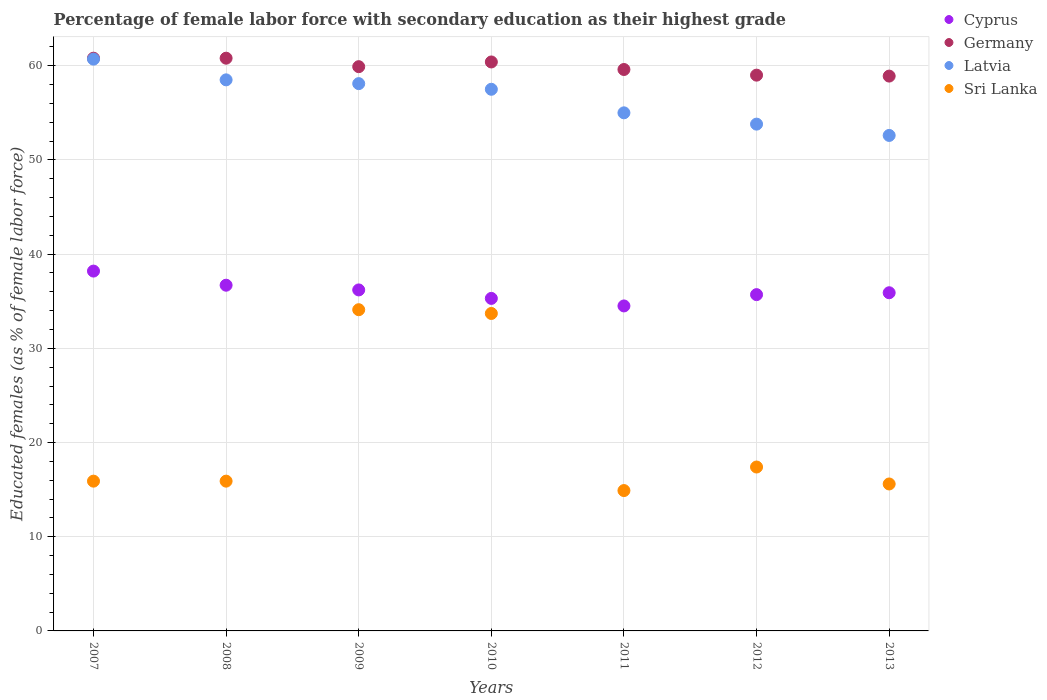How many different coloured dotlines are there?
Keep it short and to the point. 4. What is the percentage of female labor force with secondary education in Cyprus in 2008?
Your answer should be compact. 36.7. Across all years, what is the maximum percentage of female labor force with secondary education in Latvia?
Your answer should be very brief. 60.7. Across all years, what is the minimum percentage of female labor force with secondary education in Germany?
Your answer should be very brief. 58.9. In which year was the percentage of female labor force with secondary education in Sri Lanka minimum?
Give a very brief answer. 2011. What is the total percentage of female labor force with secondary education in Cyprus in the graph?
Offer a very short reply. 252.5. What is the difference between the percentage of female labor force with secondary education in Sri Lanka in 2007 and that in 2013?
Keep it short and to the point. 0.3. What is the difference between the percentage of female labor force with secondary education in Latvia in 2011 and the percentage of female labor force with secondary education in Cyprus in 2008?
Give a very brief answer. 18.3. What is the average percentage of female labor force with secondary education in Cyprus per year?
Offer a terse response. 36.07. In the year 2008, what is the difference between the percentage of female labor force with secondary education in Latvia and percentage of female labor force with secondary education in Germany?
Make the answer very short. -2.3. In how many years, is the percentage of female labor force with secondary education in Germany greater than 10 %?
Provide a succinct answer. 7. What is the ratio of the percentage of female labor force with secondary education in Germany in 2007 to that in 2011?
Your response must be concise. 1.02. Is the percentage of female labor force with secondary education in Sri Lanka in 2010 less than that in 2012?
Make the answer very short. No. What is the difference between the highest and the second highest percentage of female labor force with secondary education in Latvia?
Give a very brief answer. 2.2. What is the difference between the highest and the lowest percentage of female labor force with secondary education in Latvia?
Keep it short and to the point. 8.1. Is the sum of the percentage of female labor force with secondary education in Sri Lanka in 2007 and 2011 greater than the maximum percentage of female labor force with secondary education in Cyprus across all years?
Keep it short and to the point. No. Is it the case that in every year, the sum of the percentage of female labor force with secondary education in Sri Lanka and percentage of female labor force with secondary education in Cyprus  is greater than the sum of percentage of female labor force with secondary education in Latvia and percentage of female labor force with secondary education in Germany?
Keep it short and to the point. No. Is the percentage of female labor force with secondary education in Cyprus strictly less than the percentage of female labor force with secondary education in Latvia over the years?
Your answer should be compact. Yes. How many years are there in the graph?
Give a very brief answer. 7. Are the values on the major ticks of Y-axis written in scientific E-notation?
Make the answer very short. No. Does the graph contain any zero values?
Offer a very short reply. No. Does the graph contain grids?
Give a very brief answer. Yes. Where does the legend appear in the graph?
Your answer should be very brief. Top right. How are the legend labels stacked?
Your answer should be compact. Vertical. What is the title of the graph?
Give a very brief answer. Percentage of female labor force with secondary education as their highest grade. Does "India" appear as one of the legend labels in the graph?
Provide a short and direct response. No. What is the label or title of the X-axis?
Provide a succinct answer. Years. What is the label or title of the Y-axis?
Provide a short and direct response. Educated females (as % of female labor force). What is the Educated females (as % of female labor force) of Cyprus in 2007?
Make the answer very short. 38.2. What is the Educated females (as % of female labor force) of Germany in 2007?
Your response must be concise. 60.8. What is the Educated females (as % of female labor force) of Latvia in 2007?
Provide a succinct answer. 60.7. What is the Educated females (as % of female labor force) of Sri Lanka in 2007?
Offer a terse response. 15.9. What is the Educated females (as % of female labor force) of Cyprus in 2008?
Keep it short and to the point. 36.7. What is the Educated females (as % of female labor force) of Germany in 2008?
Your response must be concise. 60.8. What is the Educated females (as % of female labor force) of Latvia in 2008?
Your answer should be very brief. 58.5. What is the Educated females (as % of female labor force) of Sri Lanka in 2008?
Provide a succinct answer. 15.9. What is the Educated females (as % of female labor force) of Cyprus in 2009?
Make the answer very short. 36.2. What is the Educated females (as % of female labor force) in Germany in 2009?
Make the answer very short. 59.9. What is the Educated females (as % of female labor force) of Latvia in 2009?
Ensure brevity in your answer.  58.1. What is the Educated females (as % of female labor force) in Sri Lanka in 2009?
Make the answer very short. 34.1. What is the Educated females (as % of female labor force) of Cyprus in 2010?
Provide a succinct answer. 35.3. What is the Educated females (as % of female labor force) in Germany in 2010?
Ensure brevity in your answer.  60.4. What is the Educated females (as % of female labor force) of Latvia in 2010?
Offer a terse response. 57.5. What is the Educated females (as % of female labor force) of Sri Lanka in 2010?
Ensure brevity in your answer.  33.7. What is the Educated females (as % of female labor force) of Cyprus in 2011?
Ensure brevity in your answer.  34.5. What is the Educated females (as % of female labor force) in Germany in 2011?
Ensure brevity in your answer.  59.6. What is the Educated females (as % of female labor force) in Sri Lanka in 2011?
Provide a succinct answer. 14.9. What is the Educated females (as % of female labor force) of Cyprus in 2012?
Provide a short and direct response. 35.7. What is the Educated females (as % of female labor force) in Latvia in 2012?
Ensure brevity in your answer.  53.8. What is the Educated females (as % of female labor force) of Sri Lanka in 2012?
Your answer should be compact. 17.4. What is the Educated females (as % of female labor force) in Cyprus in 2013?
Give a very brief answer. 35.9. What is the Educated females (as % of female labor force) in Germany in 2013?
Provide a succinct answer. 58.9. What is the Educated females (as % of female labor force) of Latvia in 2013?
Your answer should be very brief. 52.6. What is the Educated females (as % of female labor force) in Sri Lanka in 2013?
Your response must be concise. 15.6. Across all years, what is the maximum Educated females (as % of female labor force) of Cyprus?
Provide a short and direct response. 38.2. Across all years, what is the maximum Educated females (as % of female labor force) in Germany?
Offer a terse response. 60.8. Across all years, what is the maximum Educated females (as % of female labor force) in Latvia?
Your response must be concise. 60.7. Across all years, what is the maximum Educated females (as % of female labor force) of Sri Lanka?
Your answer should be compact. 34.1. Across all years, what is the minimum Educated females (as % of female labor force) of Cyprus?
Ensure brevity in your answer.  34.5. Across all years, what is the minimum Educated females (as % of female labor force) in Germany?
Provide a short and direct response. 58.9. Across all years, what is the minimum Educated females (as % of female labor force) in Latvia?
Your response must be concise. 52.6. Across all years, what is the minimum Educated females (as % of female labor force) of Sri Lanka?
Offer a very short reply. 14.9. What is the total Educated females (as % of female labor force) of Cyprus in the graph?
Keep it short and to the point. 252.5. What is the total Educated females (as % of female labor force) of Germany in the graph?
Provide a short and direct response. 419.4. What is the total Educated females (as % of female labor force) of Latvia in the graph?
Your answer should be compact. 396.2. What is the total Educated females (as % of female labor force) of Sri Lanka in the graph?
Make the answer very short. 147.5. What is the difference between the Educated females (as % of female labor force) of Cyprus in 2007 and that in 2008?
Your answer should be very brief. 1.5. What is the difference between the Educated females (as % of female labor force) of Sri Lanka in 2007 and that in 2008?
Offer a very short reply. 0. What is the difference between the Educated females (as % of female labor force) in Cyprus in 2007 and that in 2009?
Ensure brevity in your answer.  2. What is the difference between the Educated females (as % of female labor force) of Germany in 2007 and that in 2009?
Offer a terse response. 0.9. What is the difference between the Educated females (as % of female labor force) in Sri Lanka in 2007 and that in 2009?
Make the answer very short. -18.2. What is the difference between the Educated females (as % of female labor force) in Germany in 2007 and that in 2010?
Your answer should be compact. 0.4. What is the difference between the Educated females (as % of female labor force) in Latvia in 2007 and that in 2010?
Keep it short and to the point. 3.2. What is the difference between the Educated females (as % of female labor force) of Sri Lanka in 2007 and that in 2010?
Provide a succinct answer. -17.8. What is the difference between the Educated females (as % of female labor force) in Germany in 2007 and that in 2011?
Give a very brief answer. 1.2. What is the difference between the Educated females (as % of female labor force) of Germany in 2007 and that in 2012?
Your response must be concise. 1.8. What is the difference between the Educated females (as % of female labor force) in Latvia in 2007 and that in 2012?
Ensure brevity in your answer.  6.9. What is the difference between the Educated females (as % of female labor force) of Sri Lanka in 2007 and that in 2012?
Offer a very short reply. -1.5. What is the difference between the Educated females (as % of female labor force) in Germany in 2007 and that in 2013?
Give a very brief answer. 1.9. What is the difference between the Educated females (as % of female labor force) in Latvia in 2007 and that in 2013?
Offer a terse response. 8.1. What is the difference between the Educated females (as % of female labor force) in Sri Lanka in 2007 and that in 2013?
Offer a very short reply. 0.3. What is the difference between the Educated females (as % of female labor force) of Cyprus in 2008 and that in 2009?
Your answer should be compact. 0.5. What is the difference between the Educated females (as % of female labor force) of Germany in 2008 and that in 2009?
Your answer should be compact. 0.9. What is the difference between the Educated females (as % of female labor force) in Latvia in 2008 and that in 2009?
Ensure brevity in your answer.  0.4. What is the difference between the Educated females (as % of female labor force) in Sri Lanka in 2008 and that in 2009?
Provide a succinct answer. -18.2. What is the difference between the Educated females (as % of female labor force) in Latvia in 2008 and that in 2010?
Offer a terse response. 1. What is the difference between the Educated females (as % of female labor force) of Sri Lanka in 2008 and that in 2010?
Your response must be concise. -17.8. What is the difference between the Educated females (as % of female labor force) of Cyprus in 2008 and that in 2011?
Your answer should be compact. 2.2. What is the difference between the Educated females (as % of female labor force) in Germany in 2008 and that in 2011?
Give a very brief answer. 1.2. What is the difference between the Educated females (as % of female labor force) of Latvia in 2008 and that in 2011?
Your answer should be compact. 3.5. What is the difference between the Educated females (as % of female labor force) in Cyprus in 2008 and that in 2012?
Your answer should be very brief. 1. What is the difference between the Educated females (as % of female labor force) of Latvia in 2008 and that in 2012?
Offer a very short reply. 4.7. What is the difference between the Educated females (as % of female labor force) in Latvia in 2008 and that in 2013?
Provide a succinct answer. 5.9. What is the difference between the Educated females (as % of female labor force) in Cyprus in 2009 and that in 2010?
Provide a short and direct response. 0.9. What is the difference between the Educated females (as % of female labor force) in Latvia in 2009 and that in 2010?
Offer a terse response. 0.6. What is the difference between the Educated females (as % of female labor force) of Sri Lanka in 2009 and that in 2010?
Offer a terse response. 0.4. What is the difference between the Educated females (as % of female labor force) in Cyprus in 2009 and that in 2011?
Offer a terse response. 1.7. What is the difference between the Educated females (as % of female labor force) in Sri Lanka in 2009 and that in 2011?
Give a very brief answer. 19.2. What is the difference between the Educated females (as % of female labor force) in Germany in 2009 and that in 2012?
Offer a very short reply. 0.9. What is the difference between the Educated females (as % of female labor force) of Latvia in 2009 and that in 2012?
Your response must be concise. 4.3. What is the difference between the Educated females (as % of female labor force) of Sri Lanka in 2009 and that in 2012?
Provide a succinct answer. 16.7. What is the difference between the Educated females (as % of female labor force) in Germany in 2009 and that in 2013?
Ensure brevity in your answer.  1. What is the difference between the Educated females (as % of female labor force) of Sri Lanka in 2009 and that in 2013?
Provide a short and direct response. 18.5. What is the difference between the Educated females (as % of female labor force) of Germany in 2010 and that in 2011?
Make the answer very short. 0.8. What is the difference between the Educated females (as % of female labor force) of Latvia in 2010 and that in 2011?
Provide a short and direct response. 2.5. What is the difference between the Educated females (as % of female labor force) of Sri Lanka in 2010 and that in 2011?
Ensure brevity in your answer.  18.8. What is the difference between the Educated females (as % of female labor force) of Germany in 2010 and that in 2012?
Offer a terse response. 1.4. What is the difference between the Educated females (as % of female labor force) of Latvia in 2010 and that in 2012?
Give a very brief answer. 3.7. What is the difference between the Educated females (as % of female labor force) in Sri Lanka in 2010 and that in 2012?
Provide a short and direct response. 16.3. What is the difference between the Educated females (as % of female labor force) in Cyprus in 2010 and that in 2013?
Offer a very short reply. -0.6. What is the difference between the Educated females (as % of female labor force) in Latvia in 2010 and that in 2013?
Provide a succinct answer. 4.9. What is the difference between the Educated females (as % of female labor force) in Sri Lanka in 2010 and that in 2013?
Offer a terse response. 18.1. What is the difference between the Educated females (as % of female labor force) in Cyprus in 2011 and that in 2012?
Your answer should be very brief. -1.2. What is the difference between the Educated females (as % of female labor force) in Germany in 2011 and that in 2012?
Offer a terse response. 0.6. What is the difference between the Educated females (as % of female labor force) in Latvia in 2011 and that in 2012?
Provide a short and direct response. 1.2. What is the difference between the Educated females (as % of female labor force) in Sri Lanka in 2011 and that in 2012?
Offer a terse response. -2.5. What is the difference between the Educated females (as % of female labor force) of Cyprus in 2012 and that in 2013?
Your response must be concise. -0.2. What is the difference between the Educated females (as % of female labor force) of Latvia in 2012 and that in 2013?
Give a very brief answer. 1.2. What is the difference between the Educated females (as % of female labor force) in Cyprus in 2007 and the Educated females (as % of female labor force) in Germany in 2008?
Your answer should be very brief. -22.6. What is the difference between the Educated females (as % of female labor force) of Cyprus in 2007 and the Educated females (as % of female labor force) of Latvia in 2008?
Offer a terse response. -20.3. What is the difference between the Educated females (as % of female labor force) in Cyprus in 2007 and the Educated females (as % of female labor force) in Sri Lanka in 2008?
Provide a succinct answer. 22.3. What is the difference between the Educated females (as % of female labor force) of Germany in 2007 and the Educated females (as % of female labor force) of Sri Lanka in 2008?
Ensure brevity in your answer.  44.9. What is the difference between the Educated females (as % of female labor force) in Latvia in 2007 and the Educated females (as % of female labor force) in Sri Lanka in 2008?
Give a very brief answer. 44.8. What is the difference between the Educated females (as % of female labor force) in Cyprus in 2007 and the Educated females (as % of female labor force) in Germany in 2009?
Provide a succinct answer. -21.7. What is the difference between the Educated females (as % of female labor force) in Cyprus in 2007 and the Educated females (as % of female labor force) in Latvia in 2009?
Provide a short and direct response. -19.9. What is the difference between the Educated females (as % of female labor force) in Germany in 2007 and the Educated females (as % of female labor force) in Latvia in 2009?
Keep it short and to the point. 2.7. What is the difference between the Educated females (as % of female labor force) in Germany in 2007 and the Educated females (as % of female labor force) in Sri Lanka in 2009?
Your response must be concise. 26.7. What is the difference between the Educated females (as % of female labor force) of Latvia in 2007 and the Educated females (as % of female labor force) of Sri Lanka in 2009?
Your answer should be very brief. 26.6. What is the difference between the Educated females (as % of female labor force) of Cyprus in 2007 and the Educated females (as % of female labor force) of Germany in 2010?
Your response must be concise. -22.2. What is the difference between the Educated females (as % of female labor force) in Cyprus in 2007 and the Educated females (as % of female labor force) in Latvia in 2010?
Provide a short and direct response. -19.3. What is the difference between the Educated females (as % of female labor force) in Cyprus in 2007 and the Educated females (as % of female labor force) in Sri Lanka in 2010?
Offer a very short reply. 4.5. What is the difference between the Educated females (as % of female labor force) in Germany in 2007 and the Educated females (as % of female labor force) in Sri Lanka in 2010?
Offer a very short reply. 27.1. What is the difference between the Educated females (as % of female labor force) of Cyprus in 2007 and the Educated females (as % of female labor force) of Germany in 2011?
Offer a very short reply. -21.4. What is the difference between the Educated females (as % of female labor force) in Cyprus in 2007 and the Educated females (as % of female labor force) in Latvia in 2011?
Keep it short and to the point. -16.8. What is the difference between the Educated females (as % of female labor force) in Cyprus in 2007 and the Educated females (as % of female labor force) in Sri Lanka in 2011?
Provide a succinct answer. 23.3. What is the difference between the Educated females (as % of female labor force) in Germany in 2007 and the Educated females (as % of female labor force) in Latvia in 2011?
Make the answer very short. 5.8. What is the difference between the Educated females (as % of female labor force) in Germany in 2007 and the Educated females (as % of female labor force) in Sri Lanka in 2011?
Offer a very short reply. 45.9. What is the difference between the Educated females (as % of female labor force) of Latvia in 2007 and the Educated females (as % of female labor force) of Sri Lanka in 2011?
Offer a terse response. 45.8. What is the difference between the Educated females (as % of female labor force) of Cyprus in 2007 and the Educated females (as % of female labor force) of Germany in 2012?
Offer a very short reply. -20.8. What is the difference between the Educated females (as % of female labor force) in Cyprus in 2007 and the Educated females (as % of female labor force) in Latvia in 2012?
Give a very brief answer. -15.6. What is the difference between the Educated females (as % of female labor force) in Cyprus in 2007 and the Educated females (as % of female labor force) in Sri Lanka in 2012?
Provide a short and direct response. 20.8. What is the difference between the Educated females (as % of female labor force) of Germany in 2007 and the Educated females (as % of female labor force) of Sri Lanka in 2012?
Make the answer very short. 43.4. What is the difference between the Educated females (as % of female labor force) in Latvia in 2007 and the Educated females (as % of female labor force) in Sri Lanka in 2012?
Make the answer very short. 43.3. What is the difference between the Educated females (as % of female labor force) in Cyprus in 2007 and the Educated females (as % of female labor force) in Germany in 2013?
Your response must be concise. -20.7. What is the difference between the Educated females (as % of female labor force) in Cyprus in 2007 and the Educated females (as % of female labor force) in Latvia in 2013?
Ensure brevity in your answer.  -14.4. What is the difference between the Educated females (as % of female labor force) of Cyprus in 2007 and the Educated females (as % of female labor force) of Sri Lanka in 2013?
Give a very brief answer. 22.6. What is the difference between the Educated females (as % of female labor force) in Germany in 2007 and the Educated females (as % of female labor force) in Sri Lanka in 2013?
Provide a short and direct response. 45.2. What is the difference between the Educated females (as % of female labor force) of Latvia in 2007 and the Educated females (as % of female labor force) of Sri Lanka in 2013?
Your answer should be very brief. 45.1. What is the difference between the Educated females (as % of female labor force) in Cyprus in 2008 and the Educated females (as % of female labor force) in Germany in 2009?
Offer a very short reply. -23.2. What is the difference between the Educated females (as % of female labor force) in Cyprus in 2008 and the Educated females (as % of female labor force) in Latvia in 2009?
Make the answer very short. -21.4. What is the difference between the Educated females (as % of female labor force) of Germany in 2008 and the Educated females (as % of female labor force) of Sri Lanka in 2009?
Offer a terse response. 26.7. What is the difference between the Educated females (as % of female labor force) in Latvia in 2008 and the Educated females (as % of female labor force) in Sri Lanka in 2009?
Make the answer very short. 24.4. What is the difference between the Educated females (as % of female labor force) of Cyprus in 2008 and the Educated females (as % of female labor force) of Germany in 2010?
Your answer should be very brief. -23.7. What is the difference between the Educated females (as % of female labor force) of Cyprus in 2008 and the Educated females (as % of female labor force) of Latvia in 2010?
Offer a very short reply. -20.8. What is the difference between the Educated females (as % of female labor force) in Germany in 2008 and the Educated females (as % of female labor force) in Latvia in 2010?
Provide a succinct answer. 3.3. What is the difference between the Educated females (as % of female labor force) in Germany in 2008 and the Educated females (as % of female labor force) in Sri Lanka in 2010?
Offer a very short reply. 27.1. What is the difference between the Educated females (as % of female labor force) in Latvia in 2008 and the Educated females (as % of female labor force) in Sri Lanka in 2010?
Your answer should be very brief. 24.8. What is the difference between the Educated females (as % of female labor force) of Cyprus in 2008 and the Educated females (as % of female labor force) of Germany in 2011?
Give a very brief answer. -22.9. What is the difference between the Educated females (as % of female labor force) of Cyprus in 2008 and the Educated females (as % of female labor force) of Latvia in 2011?
Your response must be concise. -18.3. What is the difference between the Educated females (as % of female labor force) in Cyprus in 2008 and the Educated females (as % of female labor force) in Sri Lanka in 2011?
Provide a short and direct response. 21.8. What is the difference between the Educated females (as % of female labor force) in Germany in 2008 and the Educated females (as % of female labor force) in Latvia in 2011?
Your response must be concise. 5.8. What is the difference between the Educated females (as % of female labor force) in Germany in 2008 and the Educated females (as % of female labor force) in Sri Lanka in 2011?
Keep it short and to the point. 45.9. What is the difference between the Educated females (as % of female labor force) of Latvia in 2008 and the Educated females (as % of female labor force) of Sri Lanka in 2011?
Your answer should be very brief. 43.6. What is the difference between the Educated females (as % of female labor force) in Cyprus in 2008 and the Educated females (as % of female labor force) in Germany in 2012?
Make the answer very short. -22.3. What is the difference between the Educated females (as % of female labor force) in Cyprus in 2008 and the Educated females (as % of female labor force) in Latvia in 2012?
Your answer should be compact. -17.1. What is the difference between the Educated females (as % of female labor force) in Cyprus in 2008 and the Educated females (as % of female labor force) in Sri Lanka in 2012?
Your answer should be compact. 19.3. What is the difference between the Educated females (as % of female labor force) in Germany in 2008 and the Educated females (as % of female labor force) in Latvia in 2012?
Provide a short and direct response. 7. What is the difference between the Educated females (as % of female labor force) in Germany in 2008 and the Educated females (as % of female labor force) in Sri Lanka in 2012?
Offer a very short reply. 43.4. What is the difference between the Educated females (as % of female labor force) in Latvia in 2008 and the Educated females (as % of female labor force) in Sri Lanka in 2012?
Your response must be concise. 41.1. What is the difference between the Educated females (as % of female labor force) in Cyprus in 2008 and the Educated females (as % of female labor force) in Germany in 2013?
Offer a very short reply. -22.2. What is the difference between the Educated females (as % of female labor force) in Cyprus in 2008 and the Educated females (as % of female labor force) in Latvia in 2013?
Provide a succinct answer. -15.9. What is the difference between the Educated females (as % of female labor force) in Cyprus in 2008 and the Educated females (as % of female labor force) in Sri Lanka in 2013?
Give a very brief answer. 21.1. What is the difference between the Educated females (as % of female labor force) in Germany in 2008 and the Educated females (as % of female labor force) in Sri Lanka in 2013?
Offer a very short reply. 45.2. What is the difference between the Educated females (as % of female labor force) of Latvia in 2008 and the Educated females (as % of female labor force) of Sri Lanka in 2013?
Give a very brief answer. 42.9. What is the difference between the Educated females (as % of female labor force) of Cyprus in 2009 and the Educated females (as % of female labor force) of Germany in 2010?
Provide a short and direct response. -24.2. What is the difference between the Educated females (as % of female labor force) in Cyprus in 2009 and the Educated females (as % of female labor force) in Latvia in 2010?
Keep it short and to the point. -21.3. What is the difference between the Educated females (as % of female labor force) in Germany in 2009 and the Educated females (as % of female labor force) in Latvia in 2010?
Provide a succinct answer. 2.4. What is the difference between the Educated females (as % of female labor force) in Germany in 2009 and the Educated females (as % of female labor force) in Sri Lanka in 2010?
Ensure brevity in your answer.  26.2. What is the difference between the Educated females (as % of female labor force) in Latvia in 2009 and the Educated females (as % of female labor force) in Sri Lanka in 2010?
Provide a short and direct response. 24.4. What is the difference between the Educated females (as % of female labor force) of Cyprus in 2009 and the Educated females (as % of female labor force) of Germany in 2011?
Offer a terse response. -23.4. What is the difference between the Educated females (as % of female labor force) in Cyprus in 2009 and the Educated females (as % of female labor force) in Latvia in 2011?
Your response must be concise. -18.8. What is the difference between the Educated females (as % of female labor force) in Cyprus in 2009 and the Educated females (as % of female labor force) in Sri Lanka in 2011?
Keep it short and to the point. 21.3. What is the difference between the Educated females (as % of female labor force) in Germany in 2009 and the Educated females (as % of female labor force) in Sri Lanka in 2011?
Offer a very short reply. 45. What is the difference between the Educated females (as % of female labor force) in Latvia in 2009 and the Educated females (as % of female labor force) in Sri Lanka in 2011?
Your answer should be very brief. 43.2. What is the difference between the Educated females (as % of female labor force) in Cyprus in 2009 and the Educated females (as % of female labor force) in Germany in 2012?
Give a very brief answer. -22.8. What is the difference between the Educated females (as % of female labor force) of Cyprus in 2009 and the Educated females (as % of female labor force) of Latvia in 2012?
Provide a short and direct response. -17.6. What is the difference between the Educated females (as % of female labor force) of Cyprus in 2009 and the Educated females (as % of female labor force) of Sri Lanka in 2012?
Provide a succinct answer. 18.8. What is the difference between the Educated females (as % of female labor force) of Germany in 2009 and the Educated females (as % of female labor force) of Latvia in 2012?
Offer a terse response. 6.1. What is the difference between the Educated females (as % of female labor force) of Germany in 2009 and the Educated females (as % of female labor force) of Sri Lanka in 2012?
Provide a succinct answer. 42.5. What is the difference between the Educated females (as % of female labor force) in Latvia in 2009 and the Educated females (as % of female labor force) in Sri Lanka in 2012?
Ensure brevity in your answer.  40.7. What is the difference between the Educated females (as % of female labor force) in Cyprus in 2009 and the Educated females (as % of female labor force) in Germany in 2013?
Provide a short and direct response. -22.7. What is the difference between the Educated females (as % of female labor force) of Cyprus in 2009 and the Educated females (as % of female labor force) of Latvia in 2013?
Provide a succinct answer. -16.4. What is the difference between the Educated females (as % of female labor force) of Cyprus in 2009 and the Educated females (as % of female labor force) of Sri Lanka in 2013?
Offer a very short reply. 20.6. What is the difference between the Educated females (as % of female labor force) in Germany in 2009 and the Educated females (as % of female labor force) in Latvia in 2013?
Your response must be concise. 7.3. What is the difference between the Educated females (as % of female labor force) of Germany in 2009 and the Educated females (as % of female labor force) of Sri Lanka in 2013?
Provide a succinct answer. 44.3. What is the difference between the Educated females (as % of female labor force) in Latvia in 2009 and the Educated females (as % of female labor force) in Sri Lanka in 2013?
Make the answer very short. 42.5. What is the difference between the Educated females (as % of female labor force) in Cyprus in 2010 and the Educated females (as % of female labor force) in Germany in 2011?
Your response must be concise. -24.3. What is the difference between the Educated females (as % of female labor force) of Cyprus in 2010 and the Educated females (as % of female labor force) of Latvia in 2011?
Offer a very short reply. -19.7. What is the difference between the Educated females (as % of female labor force) in Cyprus in 2010 and the Educated females (as % of female labor force) in Sri Lanka in 2011?
Offer a very short reply. 20.4. What is the difference between the Educated females (as % of female labor force) of Germany in 2010 and the Educated females (as % of female labor force) of Sri Lanka in 2011?
Your response must be concise. 45.5. What is the difference between the Educated females (as % of female labor force) in Latvia in 2010 and the Educated females (as % of female labor force) in Sri Lanka in 2011?
Your answer should be very brief. 42.6. What is the difference between the Educated females (as % of female labor force) in Cyprus in 2010 and the Educated females (as % of female labor force) in Germany in 2012?
Give a very brief answer. -23.7. What is the difference between the Educated females (as % of female labor force) of Cyprus in 2010 and the Educated females (as % of female labor force) of Latvia in 2012?
Provide a short and direct response. -18.5. What is the difference between the Educated females (as % of female labor force) in Cyprus in 2010 and the Educated females (as % of female labor force) in Sri Lanka in 2012?
Provide a succinct answer. 17.9. What is the difference between the Educated females (as % of female labor force) of Germany in 2010 and the Educated females (as % of female labor force) of Sri Lanka in 2012?
Ensure brevity in your answer.  43. What is the difference between the Educated females (as % of female labor force) in Latvia in 2010 and the Educated females (as % of female labor force) in Sri Lanka in 2012?
Keep it short and to the point. 40.1. What is the difference between the Educated females (as % of female labor force) of Cyprus in 2010 and the Educated females (as % of female labor force) of Germany in 2013?
Give a very brief answer. -23.6. What is the difference between the Educated females (as % of female labor force) in Cyprus in 2010 and the Educated females (as % of female labor force) in Latvia in 2013?
Your answer should be compact. -17.3. What is the difference between the Educated females (as % of female labor force) in Germany in 2010 and the Educated females (as % of female labor force) in Latvia in 2013?
Your answer should be compact. 7.8. What is the difference between the Educated females (as % of female labor force) in Germany in 2010 and the Educated females (as % of female labor force) in Sri Lanka in 2013?
Offer a terse response. 44.8. What is the difference between the Educated females (as % of female labor force) of Latvia in 2010 and the Educated females (as % of female labor force) of Sri Lanka in 2013?
Your answer should be compact. 41.9. What is the difference between the Educated females (as % of female labor force) in Cyprus in 2011 and the Educated females (as % of female labor force) in Germany in 2012?
Offer a very short reply. -24.5. What is the difference between the Educated females (as % of female labor force) in Cyprus in 2011 and the Educated females (as % of female labor force) in Latvia in 2012?
Your response must be concise. -19.3. What is the difference between the Educated females (as % of female labor force) in Cyprus in 2011 and the Educated females (as % of female labor force) in Sri Lanka in 2012?
Provide a succinct answer. 17.1. What is the difference between the Educated females (as % of female labor force) of Germany in 2011 and the Educated females (as % of female labor force) of Sri Lanka in 2012?
Your answer should be very brief. 42.2. What is the difference between the Educated females (as % of female labor force) in Latvia in 2011 and the Educated females (as % of female labor force) in Sri Lanka in 2012?
Keep it short and to the point. 37.6. What is the difference between the Educated females (as % of female labor force) in Cyprus in 2011 and the Educated females (as % of female labor force) in Germany in 2013?
Your answer should be very brief. -24.4. What is the difference between the Educated females (as % of female labor force) of Cyprus in 2011 and the Educated females (as % of female labor force) of Latvia in 2013?
Make the answer very short. -18.1. What is the difference between the Educated females (as % of female labor force) in Latvia in 2011 and the Educated females (as % of female labor force) in Sri Lanka in 2013?
Your response must be concise. 39.4. What is the difference between the Educated females (as % of female labor force) in Cyprus in 2012 and the Educated females (as % of female labor force) in Germany in 2013?
Your response must be concise. -23.2. What is the difference between the Educated females (as % of female labor force) of Cyprus in 2012 and the Educated females (as % of female labor force) of Latvia in 2013?
Offer a terse response. -16.9. What is the difference between the Educated females (as % of female labor force) of Cyprus in 2012 and the Educated females (as % of female labor force) of Sri Lanka in 2013?
Your response must be concise. 20.1. What is the difference between the Educated females (as % of female labor force) in Germany in 2012 and the Educated females (as % of female labor force) in Sri Lanka in 2013?
Your answer should be very brief. 43.4. What is the difference between the Educated females (as % of female labor force) of Latvia in 2012 and the Educated females (as % of female labor force) of Sri Lanka in 2013?
Your response must be concise. 38.2. What is the average Educated females (as % of female labor force) in Cyprus per year?
Keep it short and to the point. 36.07. What is the average Educated females (as % of female labor force) in Germany per year?
Offer a terse response. 59.91. What is the average Educated females (as % of female labor force) of Latvia per year?
Make the answer very short. 56.6. What is the average Educated females (as % of female labor force) of Sri Lanka per year?
Give a very brief answer. 21.07. In the year 2007, what is the difference between the Educated females (as % of female labor force) of Cyprus and Educated females (as % of female labor force) of Germany?
Offer a terse response. -22.6. In the year 2007, what is the difference between the Educated females (as % of female labor force) in Cyprus and Educated females (as % of female labor force) in Latvia?
Make the answer very short. -22.5. In the year 2007, what is the difference between the Educated females (as % of female labor force) of Cyprus and Educated females (as % of female labor force) of Sri Lanka?
Your answer should be compact. 22.3. In the year 2007, what is the difference between the Educated females (as % of female labor force) of Germany and Educated females (as % of female labor force) of Latvia?
Offer a very short reply. 0.1. In the year 2007, what is the difference between the Educated females (as % of female labor force) of Germany and Educated females (as % of female labor force) of Sri Lanka?
Your answer should be compact. 44.9. In the year 2007, what is the difference between the Educated females (as % of female labor force) of Latvia and Educated females (as % of female labor force) of Sri Lanka?
Offer a very short reply. 44.8. In the year 2008, what is the difference between the Educated females (as % of female labor force) in Cyprus and Educated females (as % of female labor force) in Germany?
Provide a succinct answer. -24.1. In the year 2008, what is the difference between the Educated females (as % of female labor force) of Cyprus and Educated females (as % of female labor force) of Latvia?
Make the answer very short. -21.8. In the year 2008, what is the difference between the Educated females (as % of female labor force) in Cyprus and Educated females (as % of female labor force) in Sri Lanka?
Provide a succinct answer. 20.8. In the year 2008, what is the difference between the Educated females (as % of female labor force) of Germany and Educated females (as % of female labor force) of Sri Lanka?
Give a very brief answer. 44.9. In the year 2008, what is the difference between the Educated females (as % of female labor force) in Latvia and Educated females (as % of female labor force) in Sri Lanka?
Give a very brief answer. 42.6. In the year 2009, what is the difference between the Educated females (as % of female labor force) in Cyprus and Educated females (as % of female labor force) in Germany?
Provide a short and direct response. -23.7. In the year 2009, what is the difference between the Educated females (as % of female labor force) of Cyprus and Educated females (as % of female labor force) of Latvia?
Make the answer very short. -21.9. In the year 2009, what is the difference between the Educated females (as % of female labor force) in Cyprus and Educated females (as % of female labor force) in Sri Lanka?
Give a very brief answer. 2.1. In the year 2009, what is the difference between the Educated females (as % of female labor force) in Germany and Educated females (as % of female labor force) in Latvia?
Your answer should be compact. 1.8. In the year 2009, what is the difference between the Educated females (as % of female labor force) of Germany and Educated females (as % of female labor force) of Sri Lanka?
Your answer should be compact. 25.8. In the year 2009, what is the difference between the Educated females (as % of female labor force) of Latvia and Educated females (as % of female labor force) of Sri Lanka?
Your answer should be compact. 24. In the year 2010, what is the difference between the Educated females (as % of female labor force) of Cyprus and Educated females (as % of female labor force) of Germany?
Offer a terse response. -25.1. In the year 2010, what is the difference between the Educated females (as % of female labor force) of Cyprus and Educated females (as % of female labor force) of Latvia?
Give a very brief answer. -22.2. In the year 2010, what is the difference between the Educated females (as % of female labor force) in Germany and Educated females (as % of female labor force) in Latvia?
Make the answer very short. 2.9. In the year 2010, what is the difference between the Educated females (as % of female labor force) in Germany and Educated females (as % of female labor force) in Sri Lanka?
Offer a very short reply. 26.7. In the year 2010, what is the difference between the Educated females (as % of female labor force) of Latvia and Educated females (as % of female labor force) of Sri Lanka?
Offer a very short reply. 23.8. In the year 2011, what is the difference between the Educated females (as % of female labor force) in Cyprus and Educated females (as % of female labor force) in Germany?
Offer a terse response. -25.1. In the year 2011, what is the difference between the Educated females (as % of female labor force) of Cyprus and Educated females (as % of female labor force) of Latvia?
Provide a short and direct response. -20.5. In the year 2011, what is the difference between the Educated females (as % of female labor force) in Cyprus and Educated females (as % of female labor force) in Sri Lanka?
Provide a succinct answer. 19.6. In the year 2011, what is the difference between the Educated females (as % of female labor force) in Germany and Educated females (as % of female labor force) in Sri Lanka?
Provide a short and direct response. 44.7. In the year 2011, what is the difference between the Educated females (as % of female labor force) of Latvia and Educated females (as % of female labor force) of Sri Lanka?
Give a very brief answer. 40.1. In the year 2012, what is the difference between the Educated females (as % of female labor force) in Cyprus and Educated females (as % of female labor force) in Germany?
Offer a very short reply. -23.3. In the year 2012, what is the difference between the Educated females (as % of female labor force) in Cyprus and Educated females (as % of female labor force) in Latvia?
Your answer should be very brief. -18.1. In the year 2012, what is the difference between the Educated females (as % of female labor force) of Germany and Educated females (as % of female labor force) of Latvia?
Offer a very short reply. 5.2. In the year 2012, what is the difference between the Educated females (as % of female labor force) in Germany and Educated females (as % of female labor force) in Sri Lanka?
Provide a short and direct response. 41.6. In the year 2012, what is the difference between the Educated females (as % of female labor force) of Latvia and Educated females (as % of female labor force) of Sri Lanka?
Your answer should be compact. 36.4. In the year 2013, what is the difference between the Educated females (as % of female labor force) in Cyprus and Educated females (as % of female labor force) in Germany?
Provide a short and direct response. -23. In the year 2013, what is the difference between the Educated females (as % of female labor force) in Cyprus and Educated females (as % of female labor force) in Latvia?
Provide a succinct answer. -16.7. In the year 2013, what is the difference between the Educated females (as % of female labor force) in Cyprus and Educated females (as % of female labor force) in Sri Lanka?
Your answer should be very brief. 20.3. In the year 2013, what is the difference between the Educated females (as % of female labor force) in Germany and Educated females (as % of female labor force) in Latvia?
Offer a very short reply. 6.3. In the year 2013, what is the difference between the Educated females (as % of female labor force) in Germany and Educated females (as % of female labor force) in Sri Lanka?
Provide a succinct answer. 43.3. In the year 2013, what is the difference between the Educated females (as % of female labor force) in Latvia and Educated females (as % of female labor force) in Sri Lanka?
Make the answer very short. 37. What is the ratio of the Educated females (as % of female labor force) of Cyprus in 2007 to that in 2008?
Keep it short and to the point. 1.04. What is the ratio of the Educated females (as % of female labor force) of Germany in 2007 to that in 2008?
Provide a succinct answer. 1. What is the ratio of the Educated females (as % of female labor force) in Latvia in 2007 to that in 2008?
Provide a short and direct response. 1.04. What is the ratio of the Educated females (as % of female labor force) in Cyprus in 2007 to that in 2009?
Ensure brevity in your answer.  1.06. What is the ratio of the Educated females (as % of female labor force) in Germany in 2007 to that in 2009?
Ensure brevity in your answer.  1.01. What is the ratio of the Educated females (as % of female labor force) of Latvia in 2007 to that in 2009?
Offer a very short reply. 1.04. What is the ratio of the Educated females (as % of female labor force) in Sri Lanka in 2007 to that in 2009?
Provide a succinct answer. 0.47. What is the ratio of the Educated females (as % of female labor force) in Cyprus in 2007 to that in 2010?
Make the answer very short. 1.08. What is the ratio of the Educated females (as % of female labor force) in Germany in 2007 to that in 2010?
Ensure brevity in your answer.  1.01. What is the ratio of the Educated females (as % of female labor force) in Latvia in 2007 to that in 2010?
Offer a terse response. 1.06. What is the ratio of the Educated females (as % of female labor force) of Sri Lanka in 2007 to that in 2010?
Your response must be concise. 0.47. What is the ratio of the Educated females (as % of female labor force) of Cyprus in 2007 to that in 2011?
Provide a succinct answer. 1.11. What is the ratio of the Educated females (as % of female labor force) of Germany in 2007 to that in 2011?
Your answer should be very brief. 1.02. What is the ratio of the Educated females (as % of female labor force) of Latvia in 2007 to that in 2011?
Give a very brief answer. 1.1. What is the ratio of the Educated females (as % of female labor force) of Sri Lanka in 2007 to that in 2011?
Your response must be concise. 1.07. What is the ratio of the Educated females (as % of female labor force) in Cyprus in 2007 to that in 2012?
Keep it short and to the point. 1.07. What is the ratio of the Educated females (as % of female labor force) in Germany in 2007 to that in 2012?
Provide a succinct answer. 1.03. What is the ratio of the Educated females (as % of female labor force) of Latvia in 2007 to that in 2012?
Keep it short and to the point. 1.13. What is the ratio of the Educated females (as % of female labor force) in Sri Lanka in 2007 to that in 2012?
Your response must be concise. 0.91. What is the ratio of the Educated females (as % of female labor force) of Cyprus in 2007 to that in 2013?
Offer a very short reply. 1.06. What is the ratio of the Educated females (as % of female labor force) in Germany in 2007 to that in 2013?
Provide a short and direct response. 1.03. What is the ratio of the Educated females (as % of female labor force) of Latvia in 2007 to that in 2013?
Offer a terse response. 1.15. What is the ratio of the Educated females (as % of female labor force) of Sri Lanka in 2007 to that in 2013?
Provide a short and direct response. 1.02. What is the ratio of the Educated females (as % of female labor force) in Cyprus in 2008 to that in 2009?
Provide a short and direct response. 1.01. What is the ratio of the Educated females (as % of female labor force) in Germany in 2008 to that in 2009?
Offer a very short reply. 1.01. What is the ratio of the Educated females (as % of female labor force) in Latvia in 2008 to that in 2009?
Keep it short and to the point. 1.01. What is the ratio of the Educated females (as % of female labor force) in Sri Lanka in 2008 to that in 2009?
Keep it short and to the point. 0.47. What is the ratio of the Educated females (as % of female labor force) in Cyprus in 2008 to that in 2010?
Your answer should be compact. 1.04. What is the ratio of the Educated females (as % of female labor force) in Germany in 2008 to that in 2010?
Your answer should be very brief. 1.01. What is the ratio of the Educated females (as % of female labor force) in Latvia in 2008 to that in 2010?
Provide a short and direct response. 1.02. What is the ratio of the Educated females (as % of female labor force) in Sri Lanka in 2008 to that in 2010?
Offer a terse response. 0.47. What is the ratio of the Educated females (as % of female labor force) of Cyprus in 2008 to that in 2011?
Offer a very short reply. 1.06. What is the ratio of the Educated females (as % of female labor force) in Germany in 2008 to that in 2011?
Give a very brief answer. 1.02. What is the ratio of the Educated females (as % of female labor force) in Latvia in 2008 to that in 2011?
Your response must be concise. 1.06. What is the ratio of the Educated females (as % of female labor force) in Sri Lanka in 2008 to that in 2011?
Keep it short and to the point. 1.07. What is the ratio of the Educated females (as % of female labor force) in Cyprus in 2008 to that in 2012?
Keep it short and to the point. 1.03. What is the ratio of the Educated females (as % of female labor force) of Germany in 2008 to that in 2012?
Ensure brevity in your answer.  1.03. What is the ratio of the Educated females (as % of female labor force) in Latvia in 2008 to that in 2012?
Offer a very short reply. 1.09. What is the ratio of the Educated females (as % of female labor force) of Sri Lanka in 2008 to that in 2012?
Offer a terse response. 0.91. What is the ratio of the Educated females (as % of female labor force) of Cyprus in 2008 to that in 2013?
Your answer should be compact. 1.02. What is the ratio of the Educated females (as % of female labor force) of Germany in 2008 to that in 2013?
Provide a short and direct response. 1.03. What is the ratio of the Educated females (as % of female labor force) in Latvia in 2008 to that in 2013?
Provide a succinct answer. 1.11. What is the ratio of the Educated females (as % of female labor force) of Sri Lanka in 2008 to that in 2013?
Provide a short and direct response. 1.02. What is the ratio of the Educated females (as % of female labor force) of Cyprus in 2009 to that in 2010?
Give a very brief answer. 1.03. What is the ratio of the Educated females (as % of female labor force) of Germany in 2009 to that in 2010?
Provide a succinct answer. 0.99. What is the ratio of the Educated females (as % of female labor force) of Latvia in 2009 to that in 2010?
Provide a short and direct response. 1.01. What is the ratio of the Educated females (as % of female labor force) in Sri Lanka in 2009 to that in 2010?
Provide a succinct answer. 1.01. What is the ratio of the Educated females (as % of female labor force) of Cyprus in 2009 to that in 2011?
Ensure brevity in your answer.  1.05. What is the ratio of the Educated females (as % of female labor force) in Germany in 2009 to that in 2011?
Make the answer very short. 1. What is the ratio of the Educated females (as % of female labor force) of Latvia in 2009 to that in 2011?
Your answer should be compact. 1.06. What is the ratio of the Educated females (as % of female labor force) in Sri Lanka in 2009 to that in 2011?
Your answer should be very brief. 2.29. What is the ratio of the Educated females (as % of female labor force) of Germany in 2009 to that in 2012?
Your answer should be very brief. 1.02. What is the ratio of the Educated females (as % of female labor force) of Latvia in 2009 to that in 2012?
Keep it short and to the point. 1.08. What is the ratio of the Educated females (as % of female labor force) of Sri Lanka in 2009 to that in 2012?
Your answer should be compact. 1.96. What is the ratio of the Educated females (as % of female labor force) of Cyprus in 2009 to that in 2013?
Offer a very short reply. 1.01. What is the ratio of the Educated females (as % of female labor force) in Latvia in 2009 to that in 2013?
Your answer should be compact. 1.1. What is the ratio of the Educated females (as % of female labor force) of Sri Lanka in 2009 to that in 2013?
Your response must be concise. 2.19. What is the ratio of the Educated females (as % of female labor force) in Cyprus in 2010 to that in 2011?
Provide a succinct answer. 1.02. What is the ratio of the Educated females (as % of female labor force) of Germany in 2010 to that in 2011?
Make the answer very short. 1.01. What is the ratio of the Educated females (as % of female labor force) of Latvia in 2010 to that in 2011?
Your answer should be compact. 1.05. What is the ratio of the Educated females (as % of female labor force) in Sri Lanka in 2010 to that in 2011?
Ensure brevity in your answer.  2.26. What is the ratio of the Educated females (as % of female labor force) of Germany in 2010 to that in 2012?
Your answer should be very brief. 1.02. What is the ratio of the Educated females (as % of female labor force) in Latvia in 2010 to that in 2012?
Provide a succinct answer. 1.07. What is the ratio of the Educated females (as % of female labor force) in Sri Lanka in 2010 to that in 2012?
Your answer should be very brief. 1.94. What is the ratio of the Educated females (as % of female labor force) in Cyprus in 2010 to that in 2013?
Your answer should be very brief. 0.98. What is the ratio of the Educated females (as % of female labor force) in Germany in 2010 to that in 2013?
Keep it short and to the point. 1.03. What is the ratio of the Educated females (as % of female labor force) in Latvia in 2010 to that in 2013?
Offer a very short reply. 1.09. What is the ratio of the Educated females (as % of female labor force) of Sri Lanka in 2010 to that in 2013?
Ensure brevity in your answer.  2.16. What is the ratio of the Educated females (as % of female labor force) in Cyprus in 2011 to that in 2012?
Keep it short and to the point. 0.97. What is the ratio of the Educated females (as % of female labor force) of Germany in 2011 to that in 2012?
Provide a succinct answer. 1.01. What is the ratio of the Educated females (as % of female labor force) of Latvia in 2011 to that in 2012?
Give a very brief answer. 1.02. What is the ratio of the Educated females (as % of female labor force) in Sri Lanka in 2011 to that in 2012?
Give a very brief answer. 0.86. What is the ratio of the Educated females (as % of female labor force) of Germany in 2011 to that in 2013?
Keep it short and to the point. 1.01. What is the ratio of the Educated females (as % of female labor force) of Latvia in 2011 to that in 2013?
Offer a terse response. 1.05. What is the ratio of the Educated females (as % of female labor force) in Sri Lanka in 2011 to that in 2013?
Provide a short and direct response. 0.96. What is the ratio of the Educated females (as % of female labor force) in Cyprus in 2012 to that in 2013?
Your answer should be compact. 0.99. What is the ratio of the Educated females (as % of female labor force) in Germany in 2012 to that in 2013?
Ensure brevity in your answer.  1. What is the ratio of the Educated females (as % of female labor force) in Latvia in 2012 to that in 2013?
Your answer should be very brief. 1.02. What is the ratio of the Educated females (as % of female labor force) of Sri Lanka in 2012 to that in 2013?
Your response must be concise. 1.12. What is the difference between the highest and the lowest Educated females (as % of female labor force) in Cyprus?
Your answer should be very brief. 3.7. What is the difference between the highest and the lowest Educated females (as % of female labor force) in Germany?
Give a very brief answer. 1.9. What is the difference between the highest and the lowest Educated females (as % of female labor force) in Latvia?
Ensure brevity in your answer.  8.1. What is the difference between the highest and the lowest Educated females (as % of female labor force) of Sri Lanka?
Make the answer very short. 19.2. 